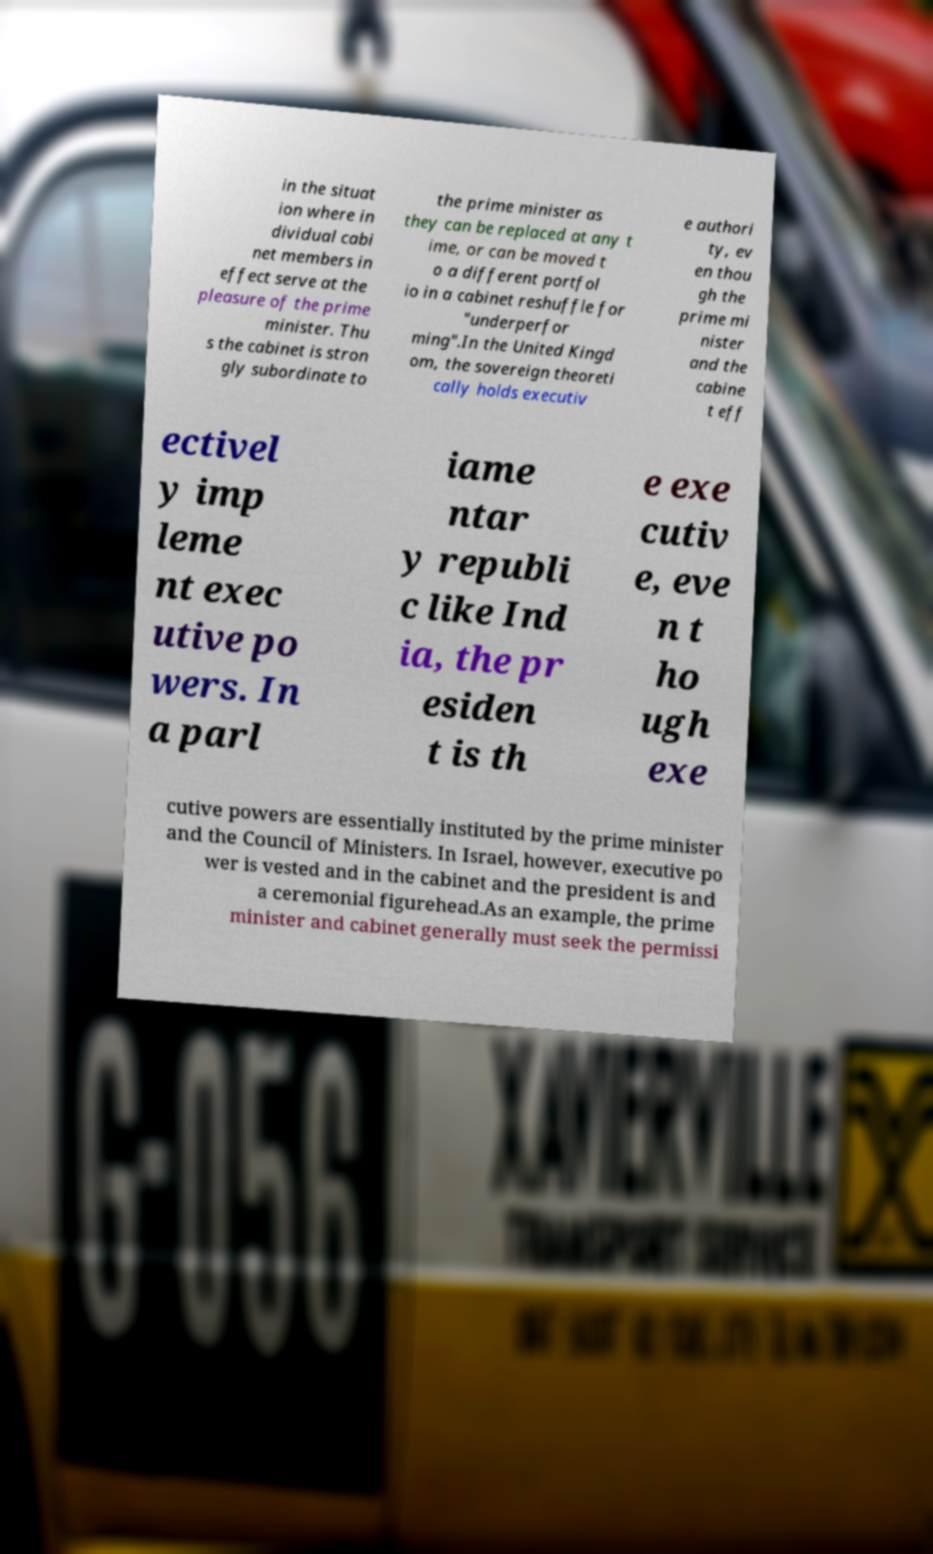Can you read and provide the text displayed in the image?This photo seems to have some interesting text. Can you extract and type it out for me? in the situat ion where in dividual cabi net members in effect serve at the pleasure of the prime minister. Thu s the cabinet is stron gly subordinate to the prime minister as they can be replaced at any t ime, or can be moved t o a different portfol io in a cabinet reshuffle for "underperfor ming".In the United Kingd om, the sovereign theoreti cally holds executiv e authori ty, ev en thou gh the prime mi nister and the cabine t eff ectivel y imp leme nt exec utive po wers. In a parl iame ntar y republi c like Ind ia, the pr esiden t is th e exe cutiv e, eve n t ho ugh exe cutive powers are essentially instituted by the prime minister and the Council of Ministers. In Israel, however, executive po wer is vested and in the cabinet and the president is and a ceremonial figurehead.As an example, the prime minister and cabinet generally must seek the permissi 